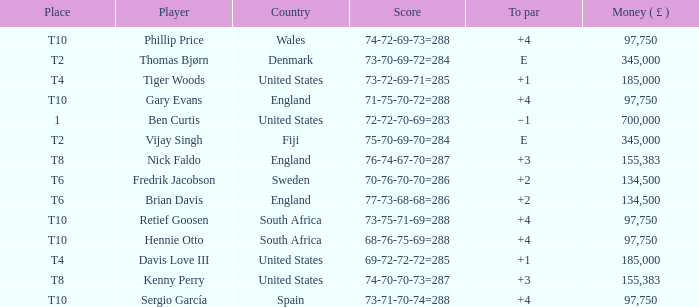What is the To Par of Fredrik Jacobson? 2.0. 